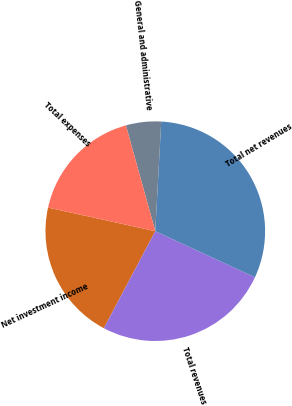Convert chart to OTSL. <chart><loc_0><loc_0><loc_500><loc_500><pie_chart><fcel>Net investment income<fcel>Total revenues<fcel>Total net revenues<fcel>General and administrative<fcel>Total expenses<nl><fcel>20.69%<fcel>25.86%<fcel>31.03%<fcel>5.17%<fcel>17.24%<nl></chart> 